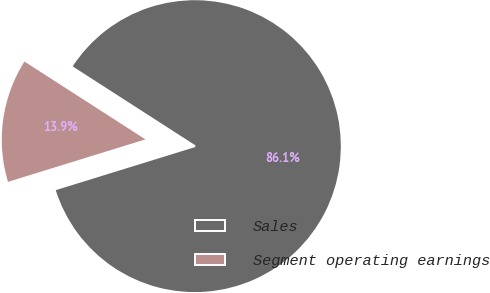Convert chart. <chart><loc_0><loc_0><loc_500><loc_500><pie_chart><fcel>Sales<fcel>Segment operating earnings<nl><fcel>86.13%<fcel>13.87%<nl></chart> 